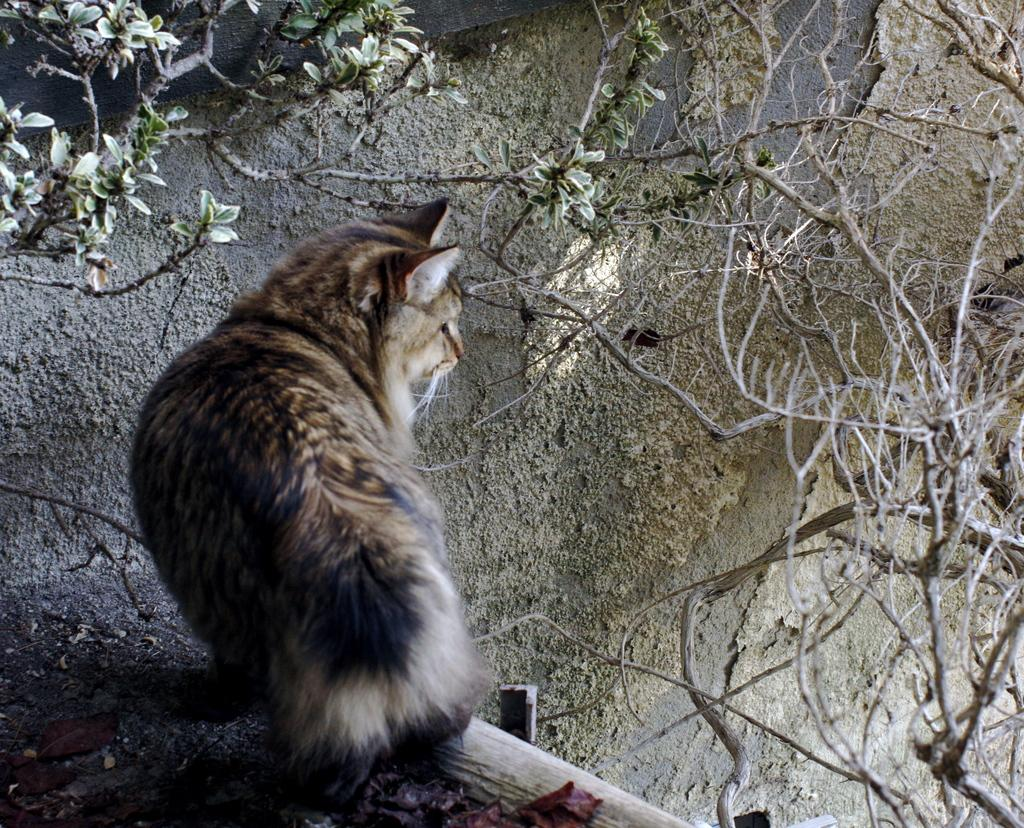What animal can be seen in the image? There is a cat in the image. What is the cat doing in the image? The cat is standing and staring at something. What is in front of the cat? There is a wall in front of the cat. What is on the wall? There are dried branches and leaves of a tree on the wall. Can you hear the cat's fang grinding in the image? There is no sound in the image, and cats do not have fangs that grind. 